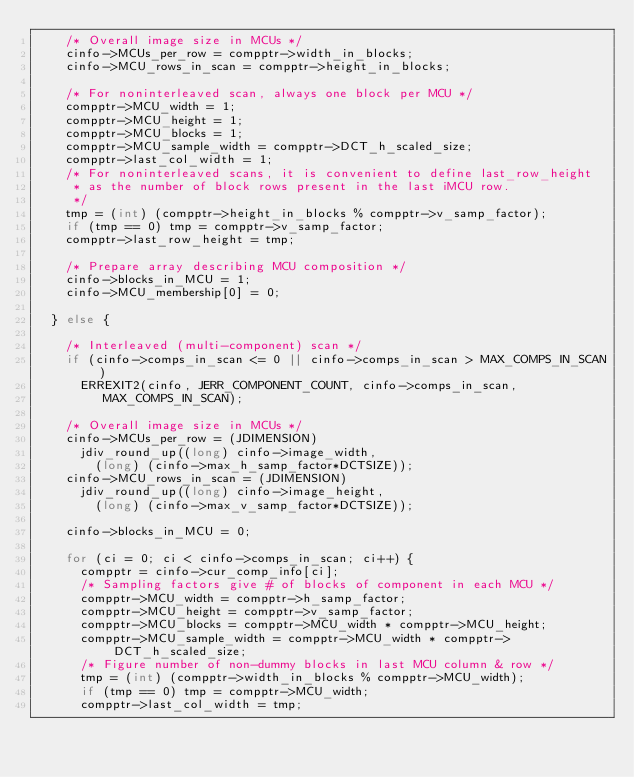Convert code to text. <code><loc_0><loc_0><loc_500><loc_500><_C_>    /* Overall image size in MCUs */
    cinfo->MCUs_per_row = compptr->width_in_blocks;
    cinfo->MCU_rows_in_scan = compptr->height_in_blocks;
    
    /* For noninterleaved scan, always one block per MCU */
    compptr->MCU_width = 1;
    compptr->MCU_height = 1;
    compptr->MCU_blocks = 1;
    compptr->MCU_sample_width = compptr->DCT_h_scaled_size;
    compptr->last_col_width = 1;
    /* For noninterleaved scans, it is convenient to define last_row_height
     * as the number of block rows present in the last iMCU row.
     */
    tmp = (int) (compptr->height_in_blocks % compptr->v_samp_factor);
    if (tmp == 0) tmp = compptr->v_samp_factor;
    compptr->last_row_height = tmp;
    
    /* Prepare array describing MCU composition */
    cinfo->blocks_in_MCU = 1;
    cinfo->MCU_membership[0] = 0;
    
  } else {
    
    /* Interleaved (multi-component) scan */
    if (cinfo->comps_in_scan <= 0 || cinfo->comps_in_scan > MAX_COMPS_IN_SCAN)
      ERREXIT2(cinfo, JERR_COMPONENT_COUNT, cinfo->comps_in_scan,
	       MAX_COMPS_IN_SCAN);
    
    /* Overall image size in MCUs */
    cinfo->MCUs_per_row = (JDIMENSION)
      jdiv_round_up((long) cinfo->image_width,
		    (long) (cinfo->max_h_samp_factor*DCTSIZE));
    cinfo->MCU_rows_in_scan = (JDIMENSION)
      jdiv_round_up((long) cinfo->image_height,
		    (long) (cinfo->max_v_samp_factor*DCTSIZE));
    
    cinfo->blocks_in_MCU = 0;
    
    for (ci = 0; ci < cinfo->comps_in_scan; ci++) {
      compptr = cinfo->cur_comp_info[ci];
      /* Sampling factors give # of blocks of component in each MCU */
      compptr->MCU_width = compptr->h_samp_factor;
      compptr->MCU_height = compptr->v_samp_factor;
      compptr->MCU_blocks = compptr->MCU_width * compptr->MCU_height;
      compptr->MCU_sample_width = compptr->MCU_width * compptr->DCT_h_scaled_size;
      /* Figure number of non-dummy blocks in last MCU column & row */
      tmp = (int) (compptr->width_in_blocks % compptr->MCU_width);
      if (tmp == 0) tmp = compptr->MCU_width;
      compptr->last_col_width = tmp;</code> 